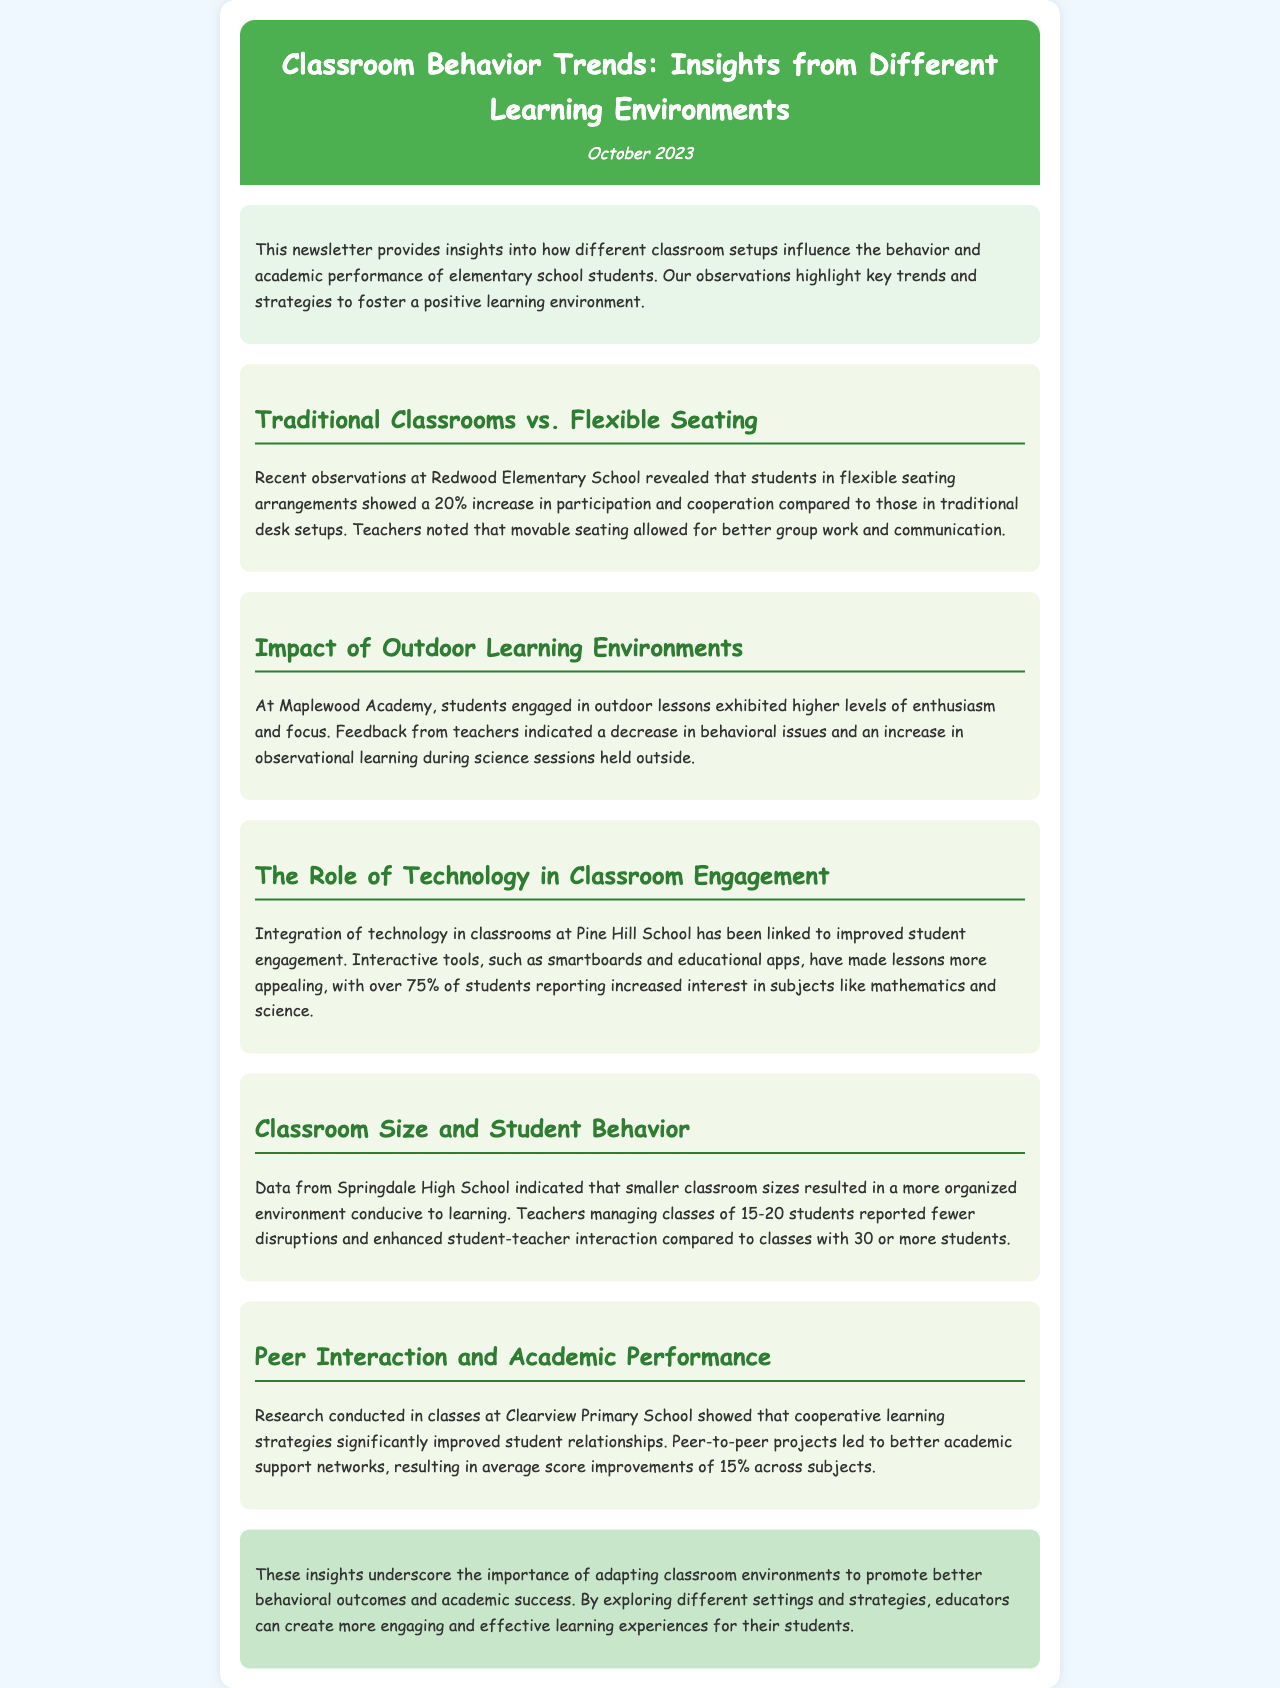What is the increase in participation for flexible seating? The increase in participation for flexible seating is reported as 20%.
Answer: 20% What positive outcome was observed from outdoor learning environments? A positive outcome observed was a decrease in behavioral issues and an increase in observational learning.
Answer: Decrease in behavioral issues What percentage of students reported increased interest due to technology integration? Over 75% of students reported increased interest in subjects like mathematics and science.
Answer: 75% What is the average score improvement from cooperative learning strategies? Average score improvements were reported at 15% across subjects due to cooperative learning strategies.
Answer: 15% How many students did teachers report fewer disruptions in classes of smaller sizes? Teachers reported fewer disruptions in classes of 15-20 students.
Answer: 15-20 students 